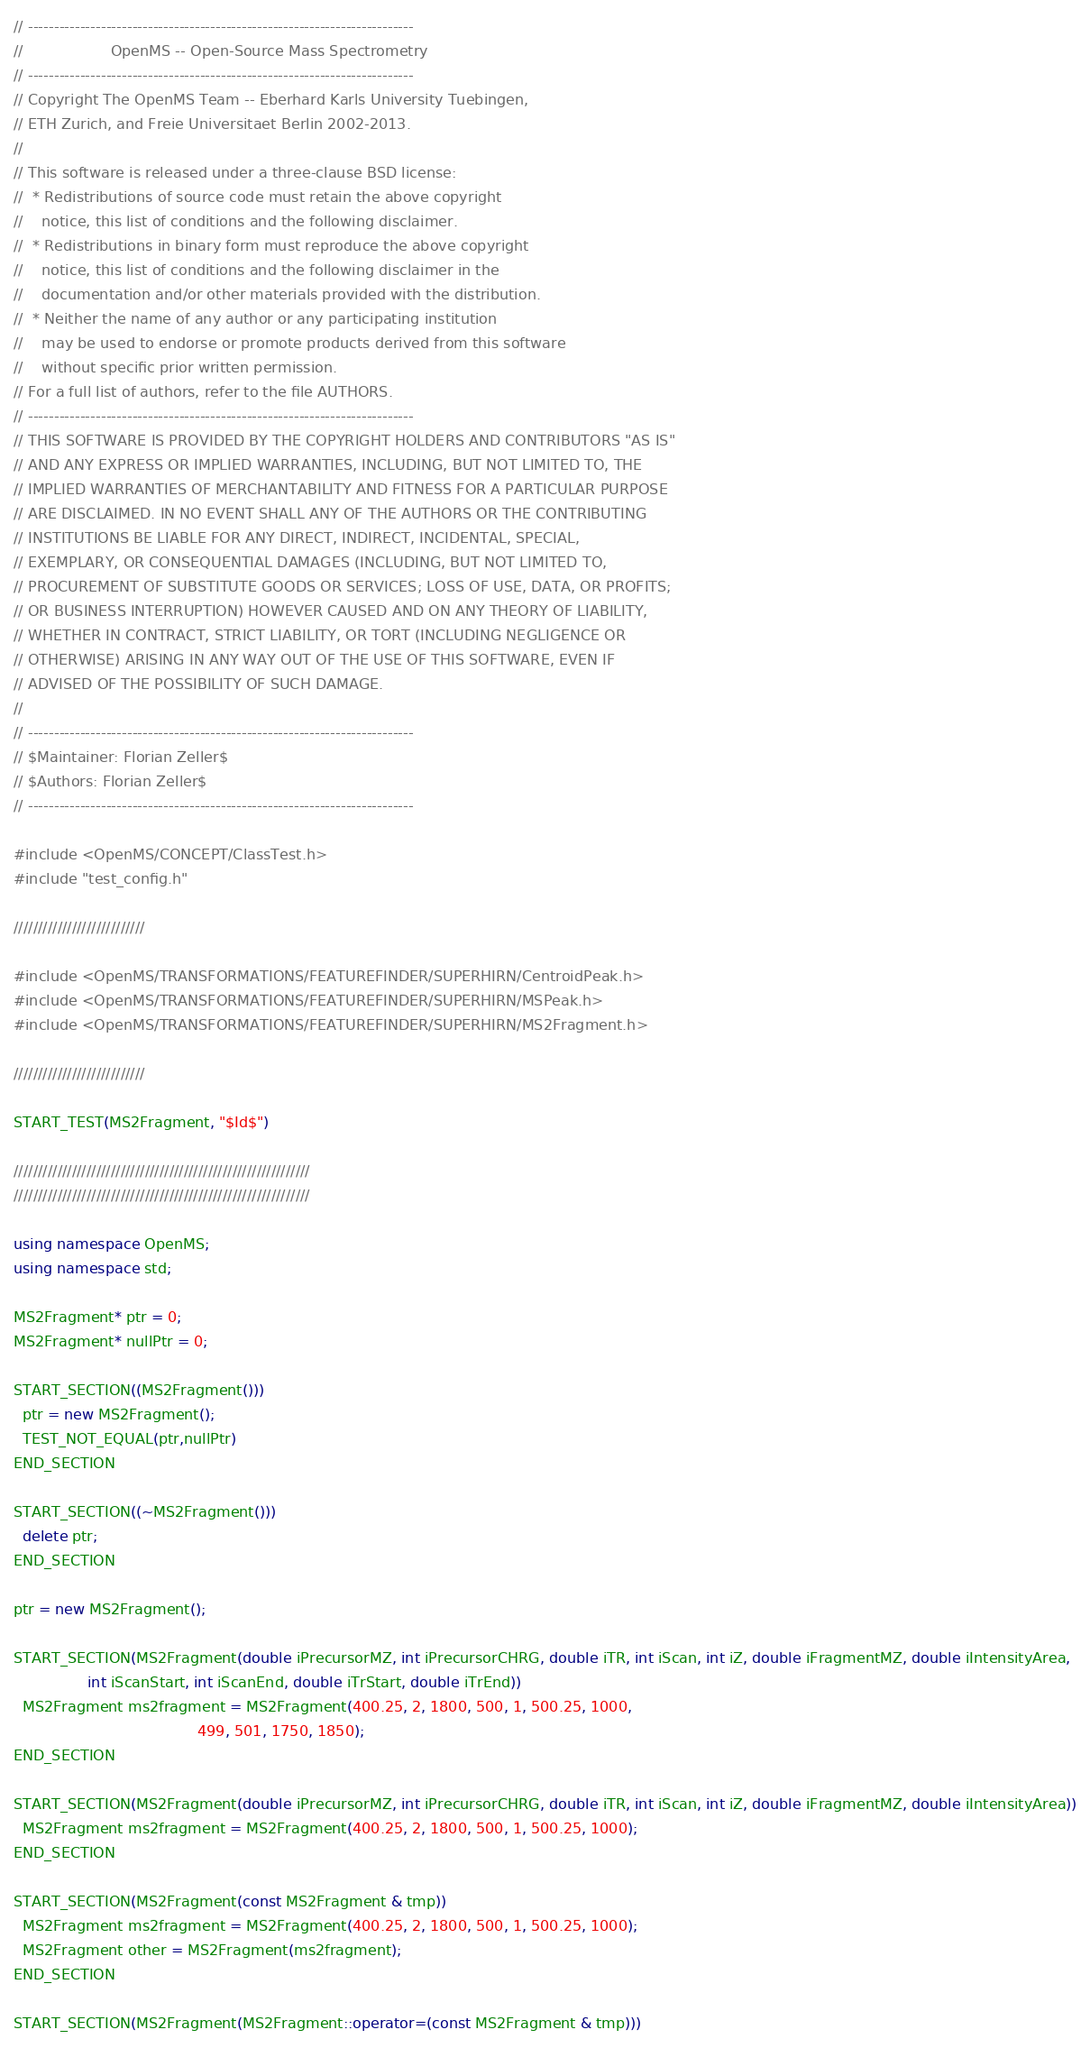Convert code to text. <code><loc_0><loc_0><loc_500><loc_500><_C++_>// --------------------------------------------------------------------------
//                   OpenMS -- Open-Source Mass Spectrometry               
// --------------------------------------------------------------------------
// Copyright The OpenMS Team -- Eberhard Karls University Tuebingen,
// ETH Zurich, and Freie Universitaet Berlin 2002-2013.
// 
// This software is released under a three-clause BSD license:
//  * Redistributions of source code must retain the above copyright
//    notice, this list of conditions and the following disclaimer.
//  * Redistributions in binary form must reproduce the above copyright
//    notice, this list of conditions and the following disclaimer in the
//    documentation and/or other materials provided with the distribution.
//  * Neither the name of any author or any participating institution 
//    may be used to endorse or promote products derived from this software 
//    without specific prior written permission.
// For a full list of authors, refer to the file AUTHORS. 
// --------------------------------------------------------------------------
// THIS SOFTWARE IS PROVIDED BY THE COPYRIGHT HOLDERS AND CONTRIBUTORS "AS IS"
// AND ANY EXPRESS OR IMPLIED WARRANTIES, INCLUDING, BUT NOT LIMITED TO, THE
// IMPLIED WARRANTIES OF MERCHANTABILITY AND FITNESS FOR A PARTICULAR PURPOSE
// ARE DISCLAIMED. IN NO EVENT SHALL ANY OF THE AUTHORS OR THE CONTRIBUTING 
// INSTITUTIONS BE LIABLE FOR ANY DIRECT, INDIRECT, INCIDENTAL, SPECIAL, 
// EXEMPLARY, OR CONSEQUENTIAL DAMAGES (INCLUDING, BUT NOT LIMITED TO, 
// PROCUREMENT OF SUBSTITUTE GOODS OR SERVICES; LOSS OF USE, DATA, OR PROFITS; 
// OR BUSINESS INTERRUPTION) HOWEVER CAUSED AND ON ANY THEORY OF LIABILITY, 
// WHETHER IN CONTRACT, STRICT LIABILITY, OR TORT (INCLUDING NEGLIGENCE OR 
// OTHERWISE) ARISING IN ANY WAY OUT OF THE USE OF THIS SOFTWARE, EVEN IF 
// ADVISED OF THE POSSIBILITY OF SUCH DAMAGE.
// 
// --------------------------------------------------------------------------
// $Maintainer: Florian Zeller$
// $Authors: Florian Zeller$
// --------------------------------------------------------------------------

#include <OpenMS/CONCEPT/ClassTest.h>
#include "test_config.h"

///////////////////////////

#include <OpenMS/TRANSFORMATIONS/FEATUREFINDER/SUPERHIRN/CentroidPeak.h>
#include <OpenMS/TRANSFORMATIONS/FEATUREFINDER/SUPERHIRN/MSPeak.h>
#include <OpenMS/TRANSFORMATIONS/FEATUREFINDER/SUPERHIRN/MS2Fragment.h>

///////////////////////////

START_TEST(MS2Fragment, "$Id$")

/////////////////////////////////////////////////////////////
/////////////////////////////////////////////////////////////

using namespace OpenMS;
using namespace std;

MS2Fragment* ptr = 0;
MS2Fragment* nullPtr = 0;

START_SECTION((MS2Fragment()))
  ptr = new MS2Fragment();
  TEST_NOT_EQUAL(ptr,nullPtr)
END_SECTION

START_SECTION((~MS2Fragment()))
  delete ptr;
END_SECTION

ptr = new MS2Fragment();

START_SECTION(MS2Fragment(double iPrecursorMZ, int iPrecursorCHRG, double iTR, int iScan, int iZ, double iFragmentMZ, double iIntensityArea,
                int iScanStart, int iScanEnd, double iTrStart, double iTrEnd))
  MS2Fragment ms2fragment = MS2Fragment(400.25, 2, 1800, 500, 1, 500.25, 1000, 
                                        499, 501, 1750, 1850);
END_SECTION

START_SECTION(MS2Fragment(double iPrecursorMZ, int iPrecursorCHRG, double iTR, int iScan, int iZ, double iFragmentMZ, double iIntensityArea))
  MS2Fragment ms2fragment = MS2Fragment(400.25, 2, 1800, 500, 1, 500.25, 1000);
END_SECTION

START_SECTION(MS2Fragment(const MS2Fragment & tmp))
  MS2Fragment ms2fragment = MS2Fragment(400.25, 2, 1800, 500, 1, 500.25, 1000);
  MS2Fragment other = MS2Fragment(ms2fragment);
END_SECTION

START_SECTION(MS2Fragment(MS2Fragment::operator=(const MS2Fragment & tmp)))</code> 